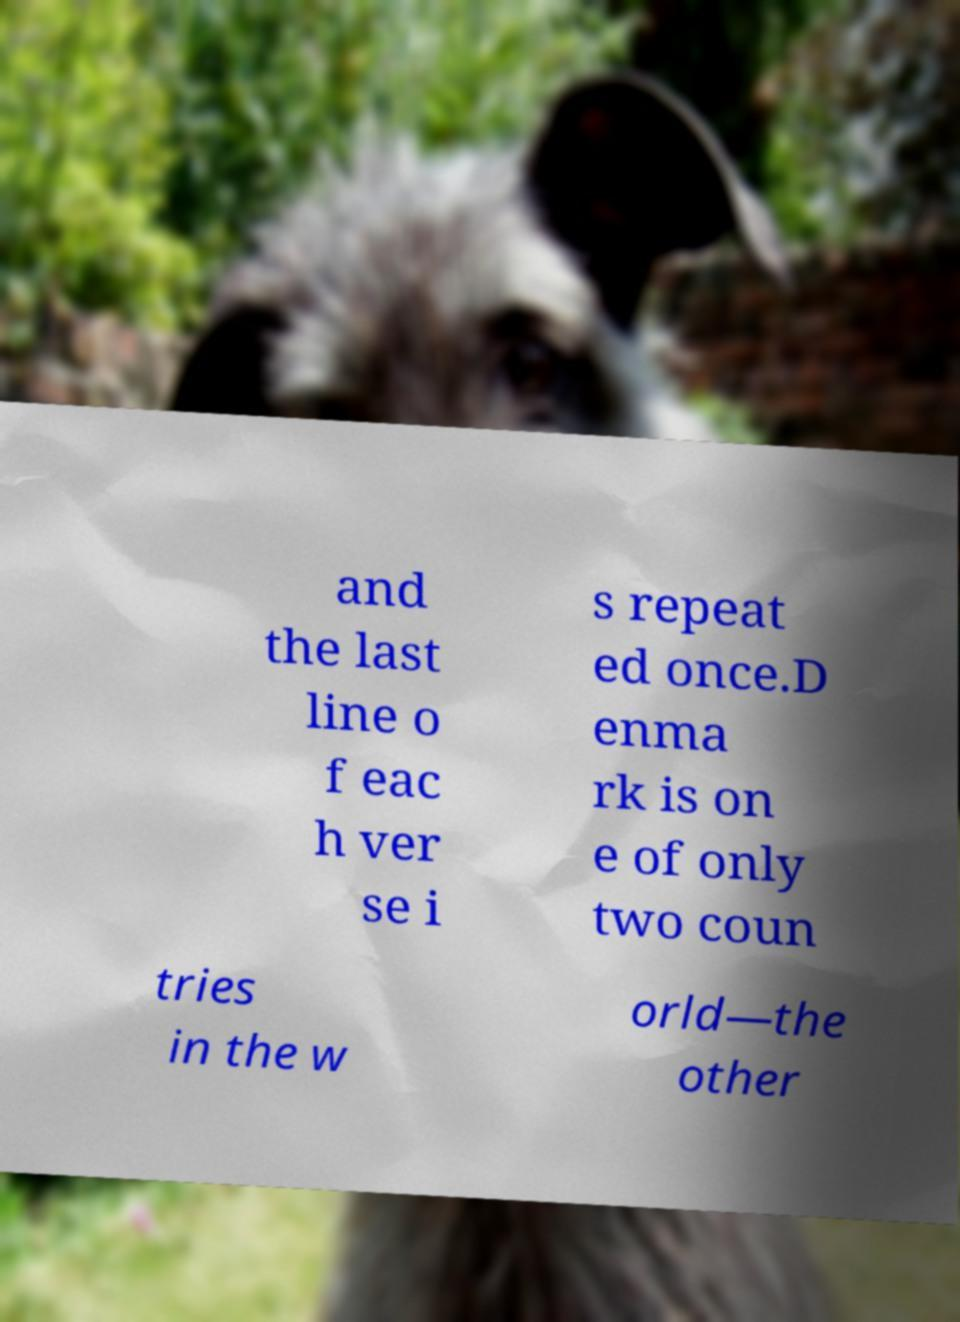There's text embedded in this image that I need extracted. Can you transcribe it verbatim? and the last line o f eac h ver se i s repeat ed once.D enma rk is on e of only two coun tries in the w orld—the other 